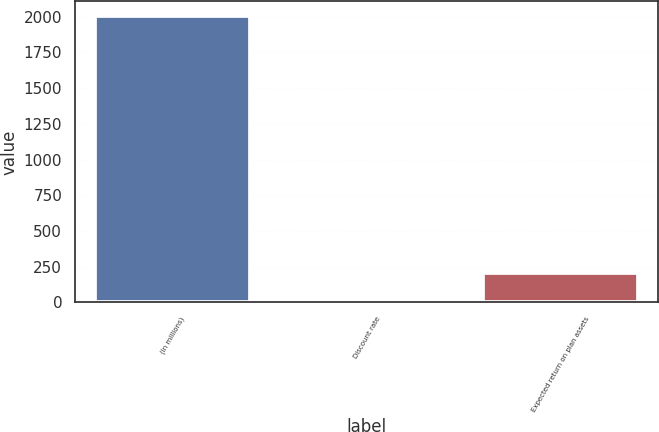Convert chart to OTSL. <chart><loc_0><loc_0><loc_500><loc_500><bar_chart><fcel>(In millions)<fcel>Discount rate<fcel>Expected return on plan assets<nl><fcel>2007<fcel>5.84<fcel>205.96<nl></chart> 